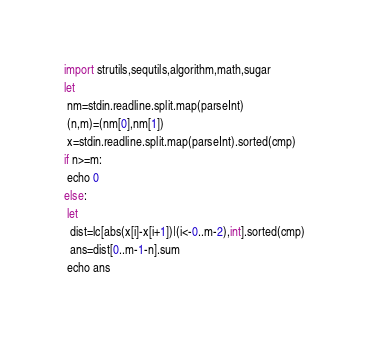<code> <loc_0><loc_0><loc_500><loc_500><_Nim_>import strutils,sequtils,algorithm,math,sugar
let
 nm=stdin.readline.split.map(parseInt)
 (n,m)=(nm[0],nm[1])
 x=stdin.readline.split.map(parseInt).sorted(cmp)
if n>=m:
 echo 0
else:
 let
  dist=lc[abs(x[i]-x[i+1])|(i<-0..m-2),int].sorted(cmp)
  ans=dist[0..m-1-n].sum
 echo ans</code> 